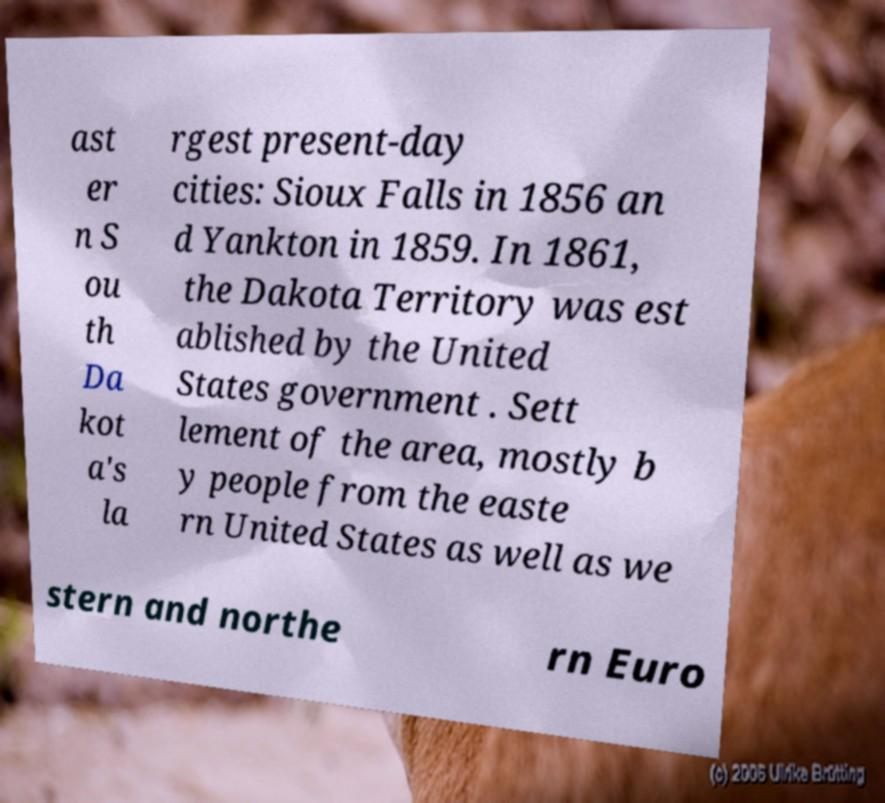For documentation purposes, I need the text within this image transcribed. Could you provide that? ast er n S ou th Da kot a's la rgest present-day cities: Sioux Falls in 1856 an d Yankton in 1859. In 1861, the Dakota Territory was est ablished by the United States government . Sett lement of the area, mostly b y people from the easte rn United States as well as we stern and northe rn Euro 